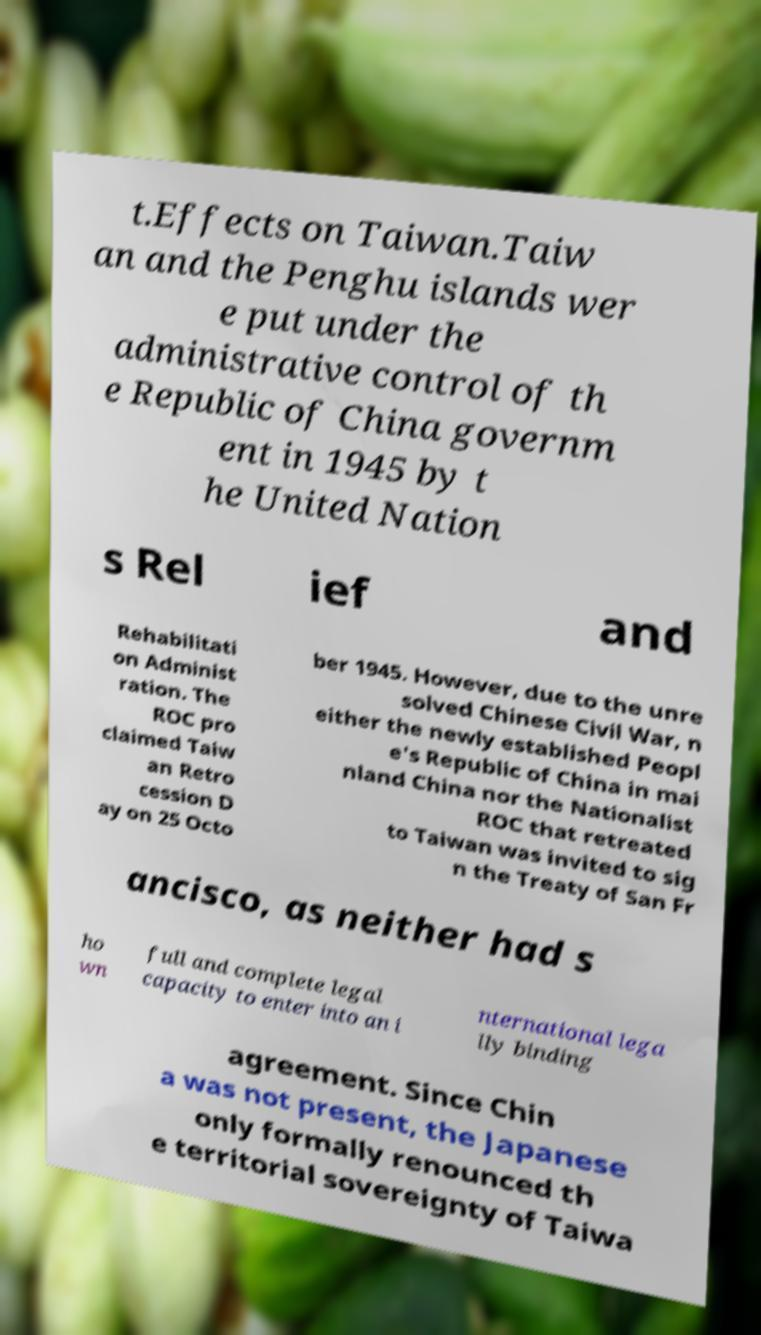Please identify and transcribe the text found in this image. t.Effects on Taiwan.Taiw an and the Penghu islands wer e put under the administrative control of th e Republic of China governm ent in 1945 by t he United Nation s Rel ief and Rehabilitati on Administ ration. The ROC pro claimed Taiw an Retro cession D ay on 25 Octo ber 1945. However, due to the unre solved Chinese Civil War, n either the newly established Peopl e's Republic of China in mai nland China nor the Nationalist ROC that retreated to Taiwan was invited to sig n the Treaty of San Fr ancisco, as neither had s ho wn full and complete legal capacity to enter into an i nternational lega lly binding agreement. Since Chin a was not present, the Japanese only formally renounced th e territorial sovereignty of Taiwa 